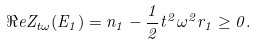<formula> <loc_0><loc_0><loc_500><loc_500>\Re e Z _ { t \omega } ( E _ { 1 } ) = n _ { 1 } - \frac { 1 } { 2 } t ^ { 2 } \omega ^ { 2 } r _ { 1 } \geq 0 .</formula> 